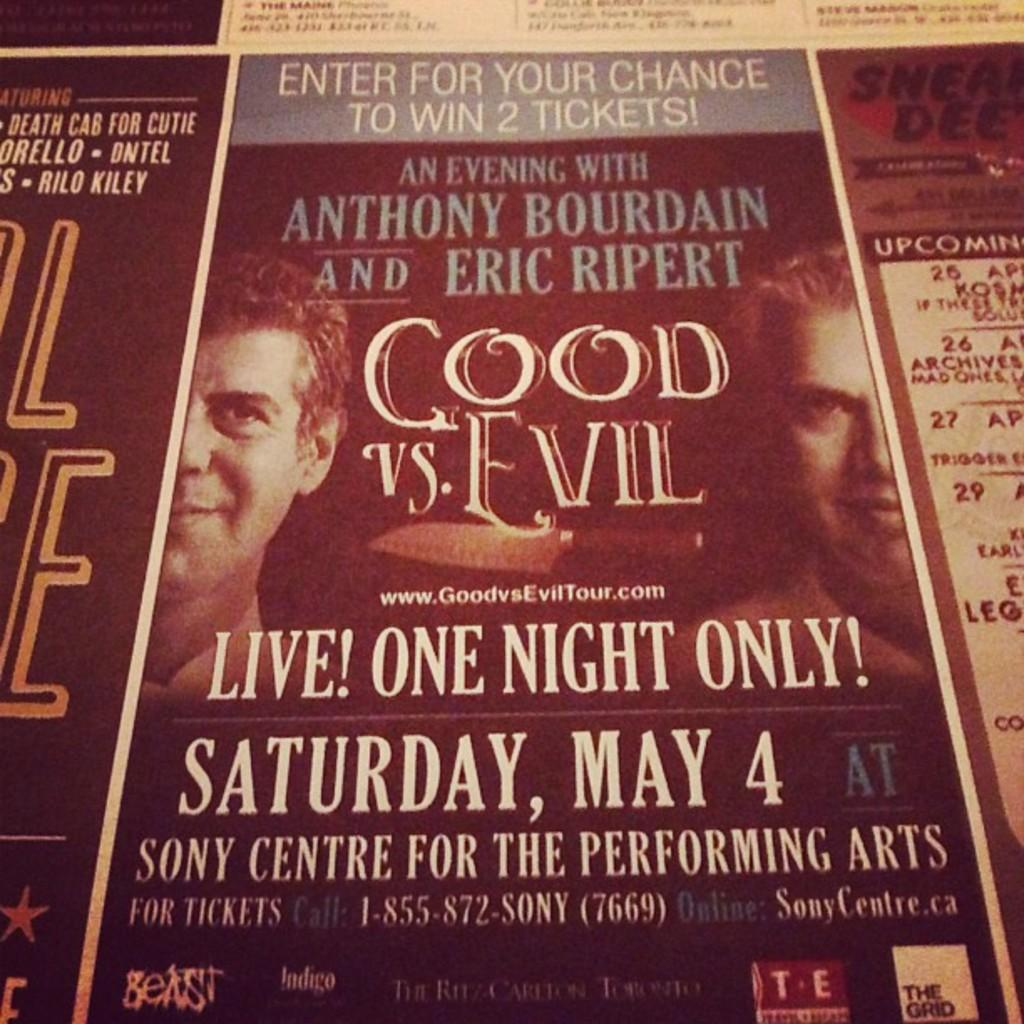<image>
Summarize the visual content of the image. a paper that says 'good vs. evil' on it 